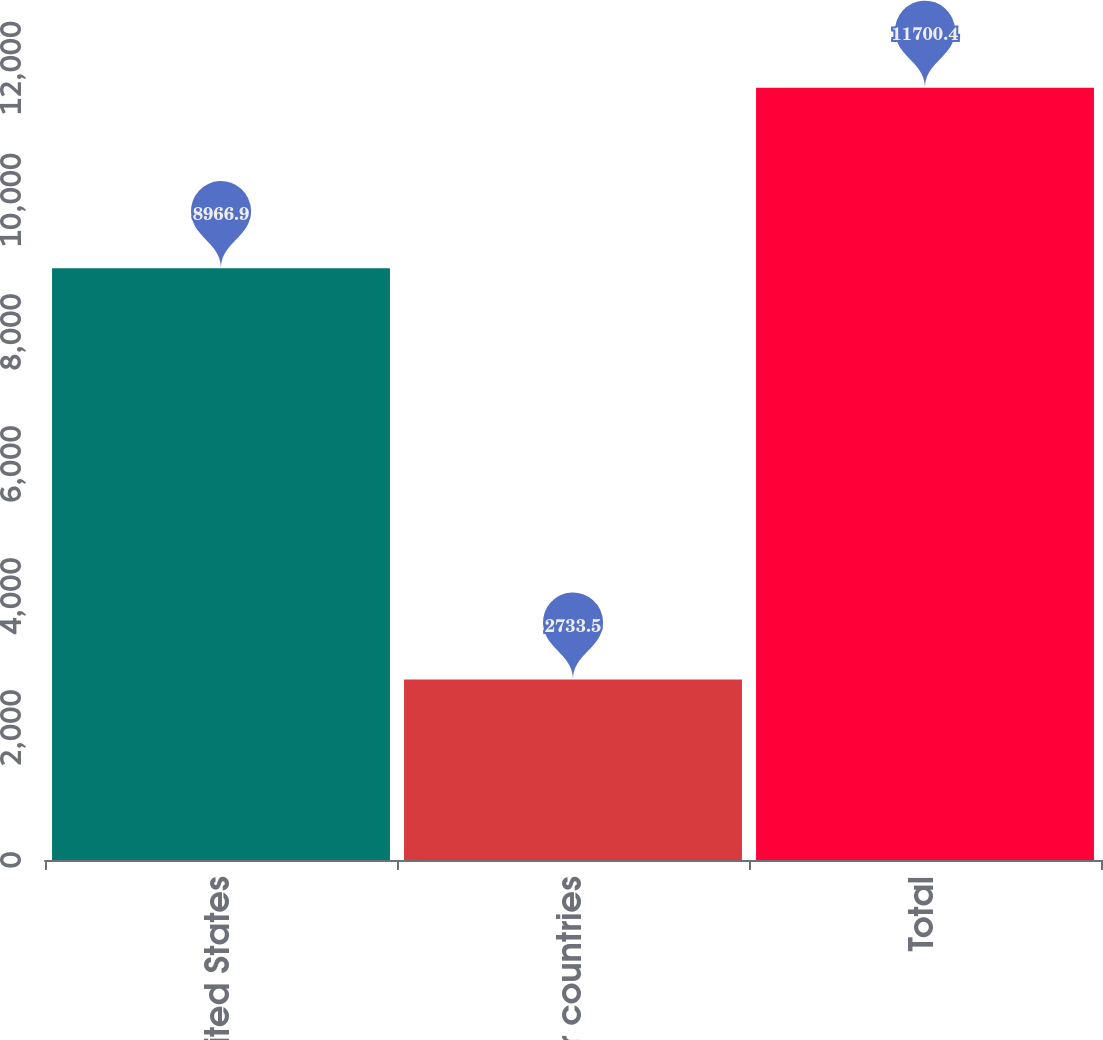Convert chart. <chart><loc_0><loc_0><loc_500><loc_500><bar_chart><fcel>United States<fcel>Other countries<fcel>Total<nl><fcel>8966.9<fcel>2733.5<fcel>11700.4<nl></chart> 